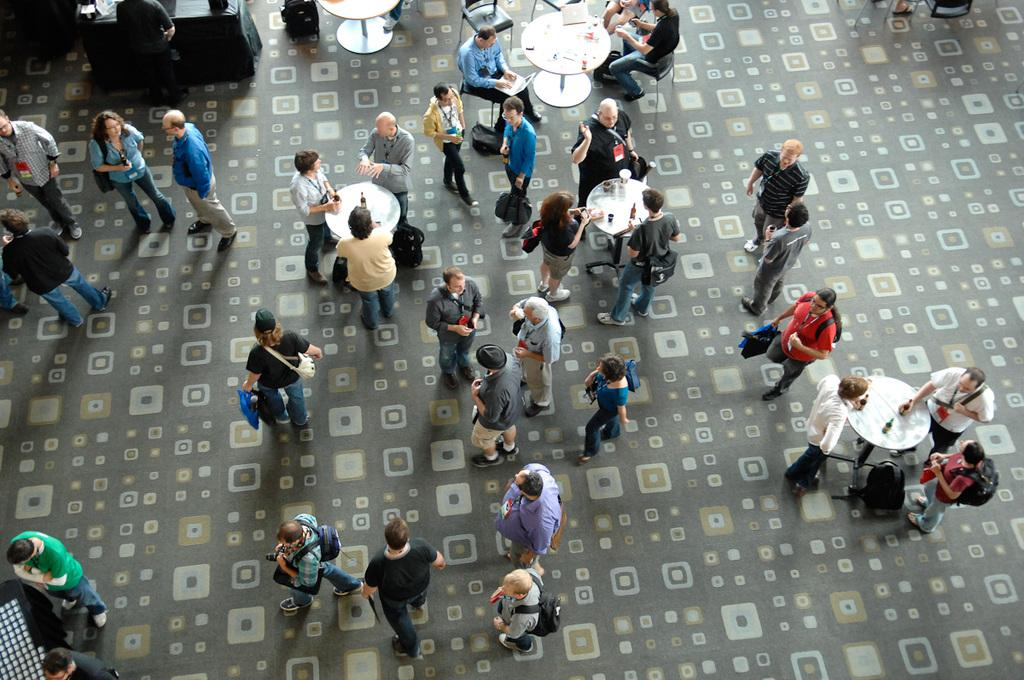What are the people in the image doing with their bags? The people in the image are carrying bags. What activity are some people engaged in at a table? Some people are standing at a table and drinking wine. What are the people sitting on chairs doing? The people sitting on chairs are operating laptops. What type of breakfast is being served at the zoo in the image? There is no mention of a zoo or breakfast in the image; it features people carrying bags, drinking wine, and operating laptops. 